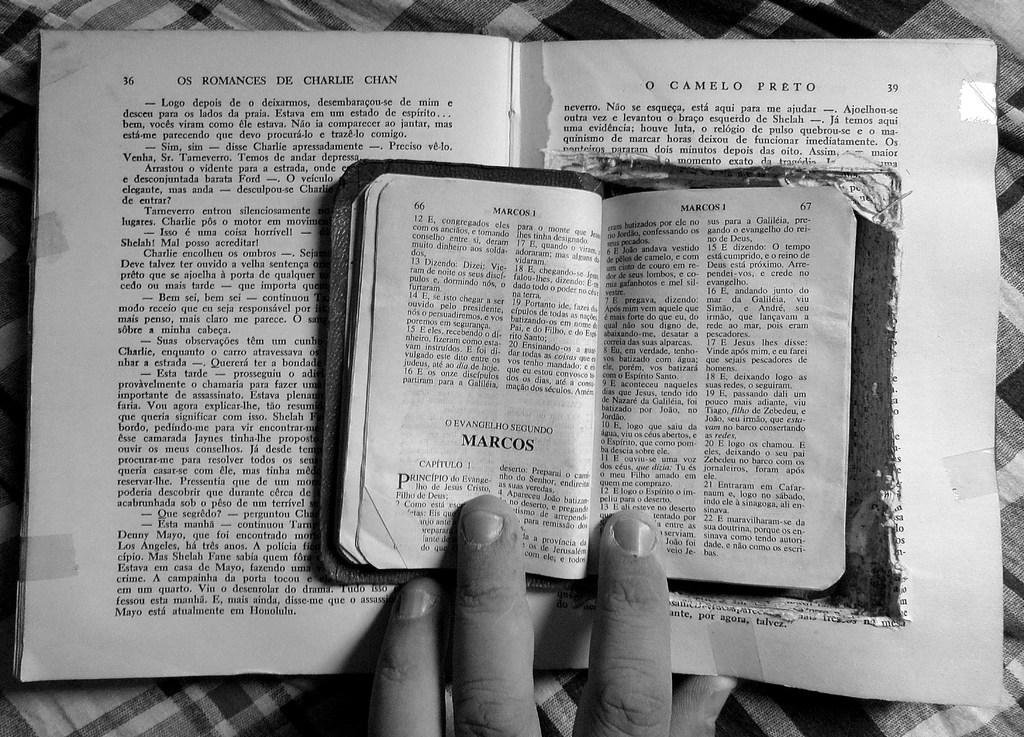What objects are on the table in the image? There are books on the table in the image. Can you describe any body parts visible in the image? A human hand is visible in the image. What is the opinion of the dad about the books in the image? There is no dad or opinion mentioned in the image, so it cannot be determined from the image. 